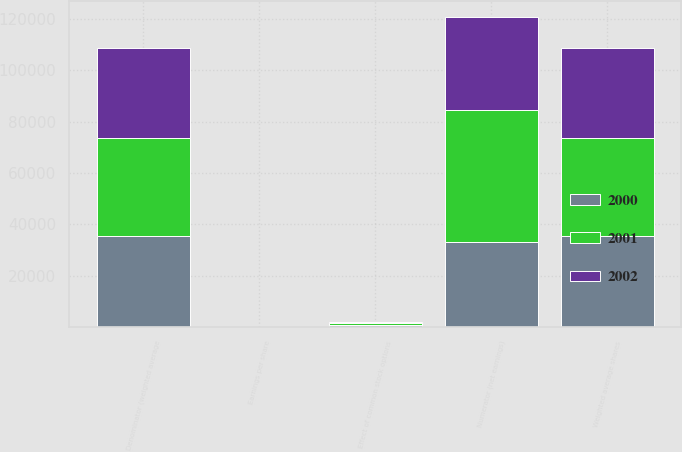Convert chart. <chart><loc_0><loc_0><loc_500><loc_500><stacked_bar_chart><ecel><fcel>Numerator (net earnings)<fcel>Denominator (weighted average<fcel>Earnings per share<fcel>Weighted average shares<fcel>Effect of common stock options<nl><fcel>2001<fcel>51816<fcel>37984<fcel>1.36<fcel>37984<fcel>1058<nl><fcel>2000<fcel>32945<fcel>35602<fcel>0.93<fcel>35602<fcel>597<nl><fcel>2002<fcel>36075<fcel>35313<fcel>1.02<fcel>35313<fcel>104<nl></chart> 